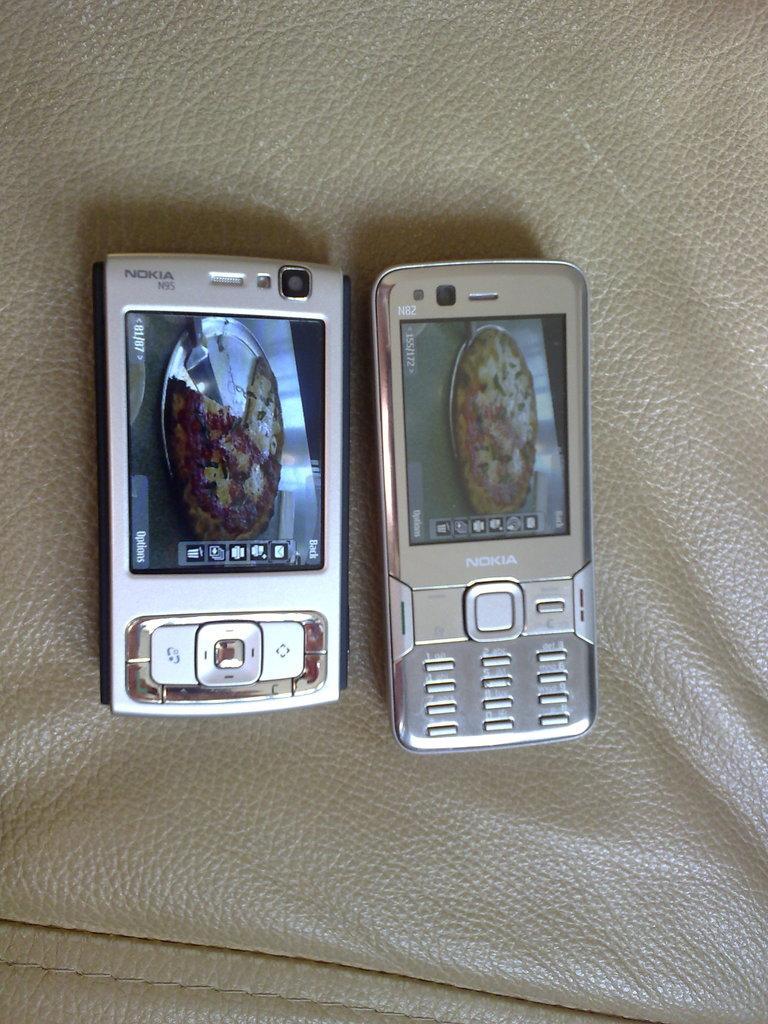Describe this image in one or two sentences. In the picture we can see two mobile phones with buttons to it which are placed on the leather mat with some stitching to it. 